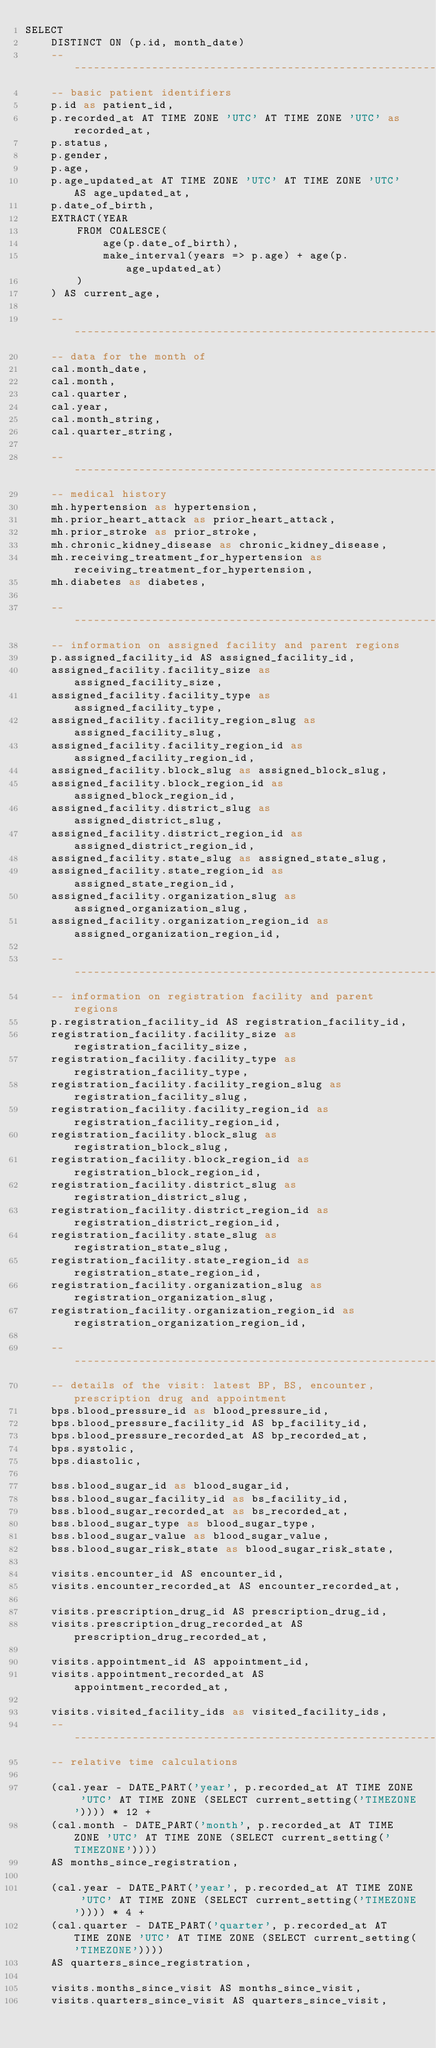<code> <loc_0><loc_0><loc_500><loc_500><_SQL_>SELECT
    DISTINCT ON (p.id, month_date)
    ------------------------------------------------------------
    -- basic patient identifiers
    p.id as patient_id,
    p.recorded_at AT TIME ZONE 'UTC' AT TIME ZONE 'UTC' as recorded_at,
    p.status,
    p.gender,
    p.age,
    p.age_updated_at AT TIME ZONE 'UTC' AT TIME ZONE 'UTC' AS age_updated_at,
    p.date_of_birth,
    EXTRACT(YEAR
        FROM COALESCE(
            age(p.date_of_birth),
            make_interval(years => p.age) + age(p.age_updated_at)
        )
    ) AS current_age,

    ------------------------------------------------------------
    -- data for the month of
    cal.month_date,
    cal.month,
    cal.quarter,
    cal.year,
    cal.month_string,
    cal.quarter_string,

    ------------------------------------------------------------
    -- medical history
    mh.hypertension as hypertension,
    mh.prior_heart_attack as prior_heart_attack,
    mh.prior_stroke as prior_stroke,
    mh.chronic_kidney_disease as chronic_kidney_disease,
    mh.receiving_treatment_for_hypertension as receiving_treatment_for_hypertension,
    mh.diabetes as diabetes,

    ------------------------------------------------------------
    -- information on assigned facility and parent regions
    p.assigned_facility_id AS assigned_facility_id,
    assigned_facility.facility_size as assigned_facility_size,
    assigned_facility.facility_type as assigned_facility_type,
    assigned_facility.facility_region_slug as assigned_facility_slug,
    assigned_facility.facility_region_id as assigned_facility_region_id,
    assigned_facility.block_slug as assigned_block_slug,
    assigned_facility.block_region_id as assigned_block_region_id,
    assigned_facility.district_slug as assigned_district_slug,
    assigned_facility.district_region_id as assigned_district_region_id,
    assigned_facility.state_slug as assigned_state_slug,
    assigned_facility.state_region_id as assigned_state_region_id,
    assigned_facility.organization_slug as assigned_organization_slug,
    assigned_facility.organization_region_id as assigned_organization_region_id,

    ------------------------------------------------------------
    -- information on registration facility and parent regions
    p.registration_facility_id AS registration_facility_id,
    registration_facility.facility_size as registration_facility_size,
    registration_facility.facility_type as registration_facility_type,
    registration_facility.facility_region_slug as registration_facility_slug,
    registration_facility.facility_region_id as registration_facility_region_id,
    registration_facility.block_slug as registration_block_slug,
    registration_facility.block_region_id as registration_block_region_id,
    registration_facility.district_slug as registration_district_slug,
    registration_facility.district_region_id as registration_district_region_id,
    registration_facility.state_slug as registration_state_slug,
    registration_facility.state_region_id as registration_state_region_id,
    registration_facility.organization_slug as registration_organization_slug,
    registration_facility.organization_region_id as registration_organization_region_id,

    ------------------------------------------------------------
    -- details of the visit: latest BP, BS, encounter, prescription drug and appointment
    bps.blood_pressure_id as blood_pressure_id,
    bps.blood_pressure_facility_id AS bp_facility_id,
    bps.blood_pressure_recorded_at AS bp_recorded_at,
    bps.systolic,
    bps.diastolic,

    bss.blood_sugar_id as blood_sugar_id,
    bss.blood_sugar_facility_id as bs_facility_id,
    bss.blood_sugar_recorded_at as bs_recorded_at,
    bss.blood_sugar_type as blood_sugar_type,
    bss.blood_sugar_value as blood_sugar_value,
    bss.blood_sugar_risk_state as blood_sugar_risk_state,

    visits.encounter_id AS encounter_id,
    visits.encounter_recorded_at AS encounter_recorded_at,

    visits.prescription_drug_id AS prescription_drug_id,
    visits.prescription_drug_recorded_at AS prescription_drug_recorded_at,

    visits.appointment_id AS appointment_id,
    visits.appointment_recorded_at AS appointment_recorded_at,

    visits.visited_facility_ids as visited_facility_ids,
    ------------------------------------------------------------
    -- relative time calculations

    (cal.year - DATE_PART('year', p.recorded_at AT TIME ZONE 'UTC' AT TIME ZONE (SELECT current_setting('TIMEZONE')))) * 12 +
    (cal.month - DATE_PART('month', p.recorded_at AT TIME ZONE 'UTC' AT TIME ZONE (SELECT current_setting('TIMEZONE'))))
    AS months_since_registration,

    (cal.year - DATE_PART('year', p.recorded_at AT TIME ZONE 'UTC' AT TIME ZONE (SELECT current_setting('TIMEZONE')))) * 4 +
    (cal.quarter - DATE_PART('quarter', p.recorded_at AT TIME ZONE 'UTC' AT TIME ZONE (SELECT current_setting('TIMEZONE'))))
    AS quarters_since_registration,

    visits.months_since_visit AS months_since_visit,
    visits.quarters_since_visit AS quarters_since_visit,</code> 